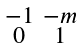<formula> <loc_0><loc_0><loc_500><loc_500>\begin{smallmatrix} - 1 & - m \\ 0 & 1 \end{smallmatrix}</formula> 